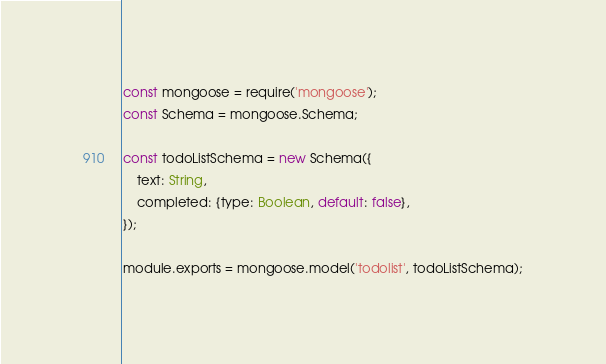<code> <loc_0><loc_0><loc_500><loc_500><_JavaScript_>const mongoose = require('mongoose');
const Schema = mongoose.Schema;

const todoListSchema = new Schema({
    text: String,
    completed: {type: Boolean, default: false},
});

module.exports = mongoose.model('todolist', todoListSchema);</code> 